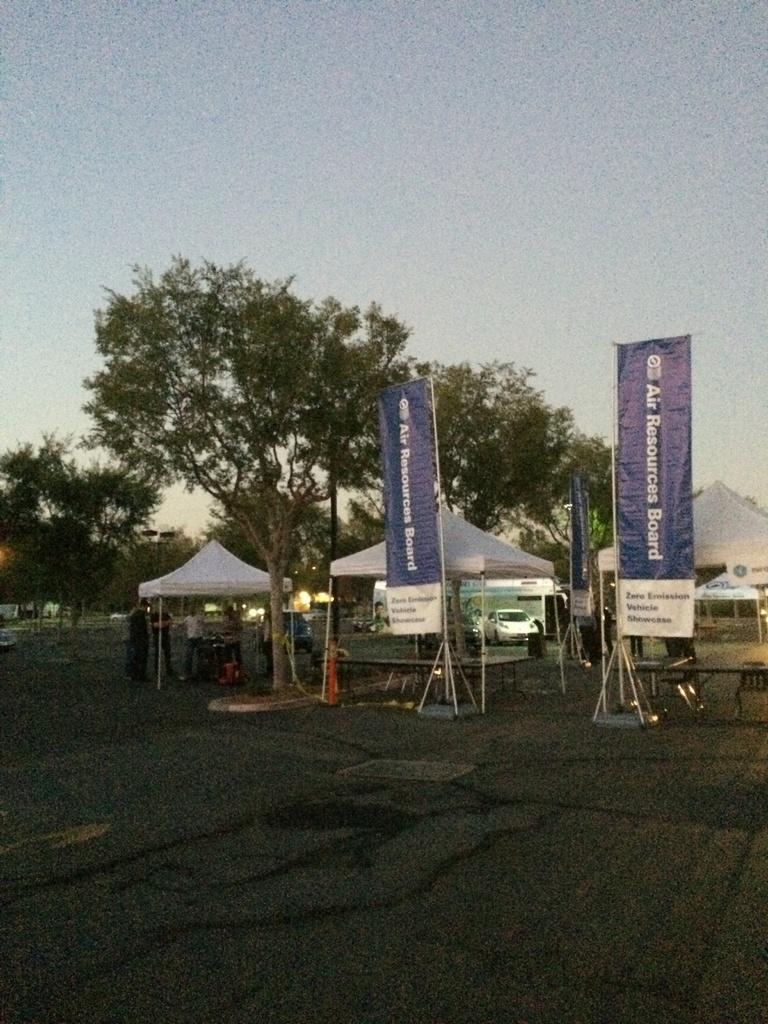What type of vegetation can be seen in the image? There are trees in the image. What type of temporary shelters are present in the image? There are tents in the image. What type of signage can be seen in the image? There are banners in the image. What type of vehicles are parked in the image? There are cars parked in the image. What are the people in the image doing? The people are standing on the road in the image. What is the weather like in the image? The sky is cloudy in the image. Where is the faucet located in the image? There is no faucet present in the image. What type of experience can be gained from the field in the image? There is no field present in the image, so it is not possible to gain any experience from it. 